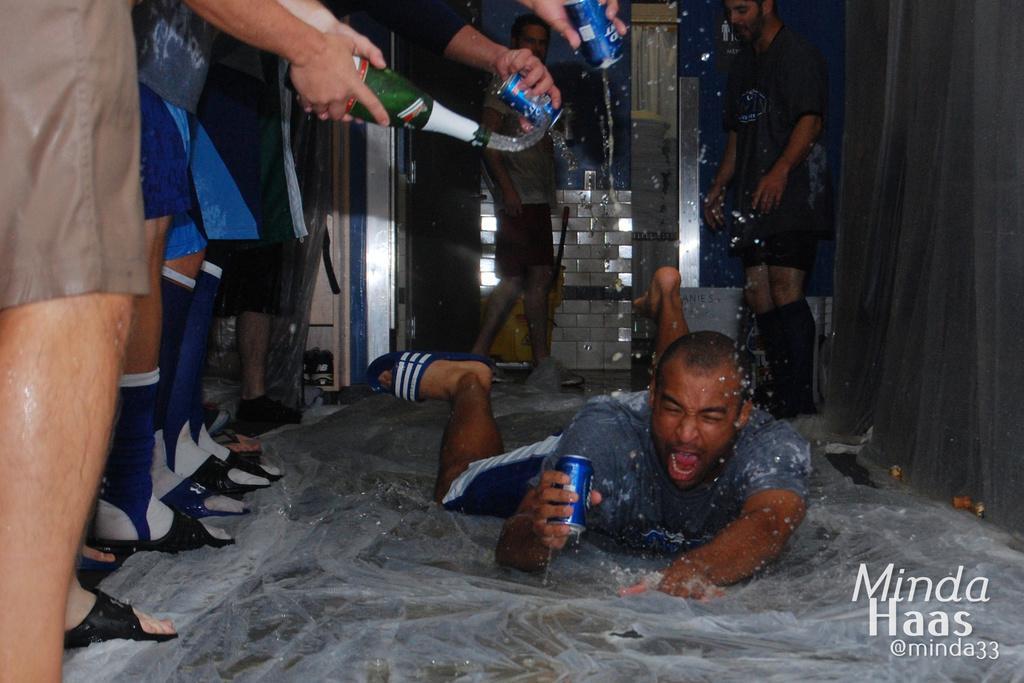Could you give a brief overview of what you see in this image? In this picture I can see there is a person lying on the floor and there is a plastic sheet on the floor, he is holding a beverage can and there is a man standing on to right side and there is a curtain on to right. In the backdrop there is a man walking and looking at the person lying on the floor and there are few people standing on to left and they are holding a wine bottle and beverage cans and pouring it on the person lying on the floor. 